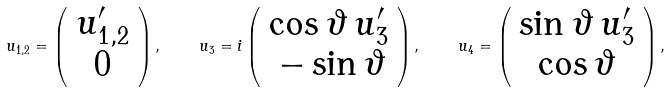<formula> <loc_0><loc_0><loc_500><loc_500>u _ { 1 , 2 } = \left ( \begin{array} { c } u ^ { \prime } _ { 1 , 2 } \\ 0 \end{array} \right ) , \quad u _ { 3 } = i \left ( \begin{array} { c } \cos \vartheta \, u ^ { \prime } _ { 3 } \\ \, - \sin \vartheta \end{array} \right ) , \quad u _ { 4 } = \left ( \begin{array} { c } \sin \vartheta \, u ^ { \prime } _ { 3 } \\ \cos \vartheta \end{array} \right ) ,</formula> 